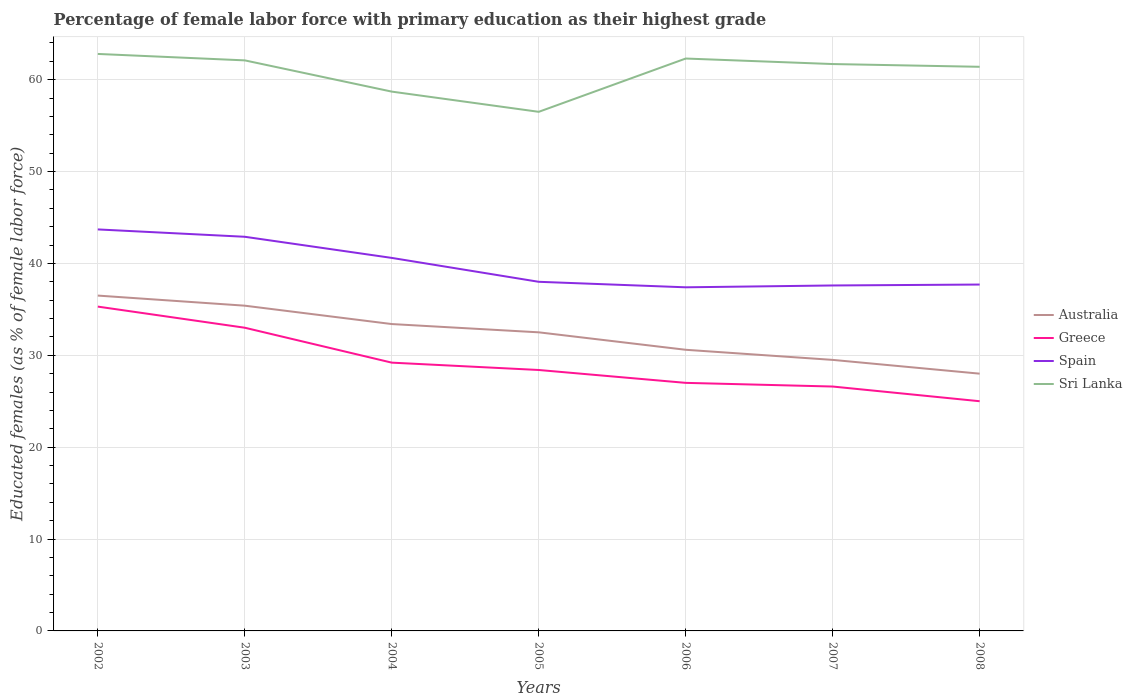In which year was the percentage of female labor force with primary education in Australia maximum?
Ensure brevity in your answer.  2008. What is the total percentage of female labor force with primary education in Greece in the graph?
Give a very brief answer. 6. What is the difference between the highest and the second highest percentage of female labor force with primary education in Greece?
Make the answer very short. 10.3. What is the difference between the highest and the lowest percentage of female labor force with primary education in Australia?
Keep it short and to the point. 4. Is the percentage of female labor force with primary education in Sri Lanka strictly greater than the percentage of female labor force with primary education in Greece over the years?
Ensure brevity in your answer.  No. How many years are there in the graph?
Ensure brevity in your answer.  7. What is the difference between two consecutive major ticks on the Y-axis?
Offer a very short reply. 10. What is the title of the graph?
Your response must be concise. Percentage of female labor force with primary education as their highest grade. Does "Burundi" appear as one of the legend labels in the graph?
Make the answer very short. No. What is the label or title of the X-axis?
Offer a terse response. Years. What is the label or title of the Y-axis?
Offer a very short reply. Educated females (as % of female labor force). What is the Educated females (as % of female labor force) in Australia in 2002?
Ensure brevity in your answer.  36.5. What is the Educated females (as % of female labor force) in Greece in 2002?
Your answer should be very brief. 35.3. What is the Educated females (as % of female labor force) in Spain in 2002?
Your answer should be compact. 43.7. What is the Educated females (as % of female labor force) in Sri Lanka in 2002?
Ensure brevity in your answer.  62.8. What is the Educated females (as % of female labor force) in Australia in 2003?
Give a very brief answer. 35.4. What is the Educated females (as % of female labor force) of Spain in 2003?
Keep it short and to the point. 42.9. What is the Educated females (as % of female labor force) in Sri Lanka in 2003?
Offer a very short reply. 62.1. What is the Educated females (as % of female labor force) of Australia in 2004?
Ensure brevity in your answer.  33.4. What is the Educated females (as % of female labor force) of Greece in 2004?
Provide a succinct answer. 29.2. What is the Educated females (as % of female labor force) in Spain in 2004?
Offer a terse response. 40.6. What is the Educated females (as % of female labor force) of Sri Lanka in 2004?
Offer a terse response. 58.7. What is the Educated females (as % of female labor force) of Australia in 2005?
Ensure brevity in your answer.  32.5. What is the Educated females (as % of female labor force) in Greece in 2005?
Provide a short and direct response. 28.4. What is the Educated females (as % of female labor force) in Spain in 2005?
Ensure brevity in your answer.  38. What is the Educated females (as % of female labor force) of Sri Lanka in 2005?
Provide a short and direct response. 56.5. What is the Educated females (as % of female labor force) of Australia in 2006?
Give a very brief answer. 30.6. What is the Educated females (as % of female labor force) of Spain in 2006?
Keep it short and to the point. 37.4. What is the Educated females (as % of female labor force) of Sri Lanka in 2006?
Keep it short and to the point. 62.3. What is the Educated females (as % of female labor force) of Australia in 2007?
Your answer should be compact. 29.5. What is the Educated females (as % of female labor force) of Greece in 2007?
Your response must be concise. 26.6. What is the Educated females (as % of female labor force) in Spain in 2007?
Your response must be concise. 37.6. What is the Educated females (as % of female labor force) in Sri Lanka in 2007?
Ensure brevity in your answer.  61.7. What is the Educated females (as % of female labor force) of Spain in 2008?
Provide a short and direct response. 37.7. What is the Educated females (as % of female labor force) of Sri Lanka in 2008?
Offer a terse response. 61.4. Across all years, what is the maximum Educated females (as % of female labor force) in Australia?
Provide a short and direct response. 36.5. Across all years, what is the maximum Educated females (as % of female labor force) of Greece?
Provide a succinct answer. 35.3. Across all years, what is the maximum Educated females (as % of female labor force) in Spain?
Provide a succinct answer. 43.7. Across all years, what is the maximum Educated females (as % of female labor force) of Sri Lanka?
Your response must be concise. 62.8. Across all years, what is the minimum Educated females (as % of female labor force) in Greece?
Provide a short and direct response. 25. Across all years, what is the minimum Educated females (as % of female labor force) of Spain?
Your answer should be compact. 37.4. Across all years, what is the minimum Educated females (as % of female labor force) in Sri Lanka?
Make the answer very short. 56.5. What is the total Educated females (as % of female labor force) in Australia in the graph?
Provide a succinct answer. 225.9. What is the total Educated females (as % of female labor force) in Greece in the graph?
Give a very brief answer. 204.5. What is the total Educated females (as % of female labor force) of Spain in the graph?
Offer a terse response. 277.9. What is the total Educated females (as % of female labor force) in Sri Lanka in the graph?
Offer a terse response. 425.5. What is the difference between the Educated females (as % of female labor force) in Australia in 2002 and that in 2003?
Give a very brief answer. 1.1. What is the difference between the Educated females (as % of female labor force) in Spain in 2002 and that in 2003?
Your answer should be very brief. 0.8. What is the difference between the Educated females (as % of female labor force) in Sri Lanka in 2002 and that in 2003?
Ensure brevity in your answer.  0.7. What is the difference between the Educated females (as % of female labor force) in Spain in 2002 and that in 2004?
Make the answer very short. 3.1. What is the difference between the Educated females (as % of female labor force) of Sri Lanka in 2002 and that in 2004?
Your answer should be very brief. 4.1. What is the difference between the Educated females (as % of female labor force) of Australia in 2002 and that in 2005?
Your response must be concise. 4. What is the difference between the Educated females (as % of female labor force) of Sri Lanka in 2002 and that in 2005?
Your answer should be compact. 6.3. What is the difference between the Educated females (as % of female labor force) in Spain in 2002 and that in 2006?
Make the answer very short. 6.3. What is the difference between the Educated females (as % of female labor force) in Australia in 2002 and that in 2007?
Your answer should be very brief. 7. What is the difference between the Educated females (as % of female labor force) in Australia in 2002 and that in 2008?
Your response must be concise. 8.5. What is the difference between the Educated females (as % of female labor force) of Greece in 2002 and that in 2008?
Offer a terse response. 10.3. What is the difference between the Educated females (as % of female labor force) in Australia in 2003 and that in 2005?
Ensure brevity in your answer.  2.9. What is the difference between the Educated females (as % of female labor force) of Australia in 2003 and that in 2006?
Offer a terse response. 4.8. What is the difference between the Educated females (as % of female labor force) in Spain in 2003 and that in 2006?
Make the answer very short. 5.5. What is the difference between the Educated females (as % of female labor force) in Sri Lanka in 2003 and that in 2006?
Ensure brevity in your answer.  -0.2. What is the difference between the Educated females (as % of female labor force) of Greece in 2003 and that in 2007?
Ensure brevity in your answer.  6.4. What is the difference between the Educated females (as % of female labor force) in Spain in 2003 and that in 2007?
Offer a terse response. 5.3. What is the difference between the Educated females (as % of female labor force) in Australia in 2003 and that in 2008?
Provide a short and direct response. 7.4. What is the difference between the Educated females (as % of female labor force) in Spain in 2004 and that in 2005?
Give a very brief answer. 2.6. What is the difference between the Educated females (as % of female labor force) of Spain in 2004 and that in 2006?
Your answer should be very brief. 3.2. What is the difference between the Educated females (as % of female labor force) of Sri Lanka in 2004 and that in 2006?
Your answer should be compact. -3.6. What is the difference between the Educated females (as % of female labor force) of Australia in 2004 and that in 2007?
Make the answer very short. 3.9. What is the difference between the Educated females (as % of female labor force) of Greece in 2004 and that in 2007?
Ensure brevity in your answer.  2.6. What is the difference between the Educated females (as % of female labor force) in Sri Lanka in 2004 and that in 2007?
Your response must be concise. -3. What is the difference between the Educated females (as % of female labor force) of Spain in 2004 and that in 2008?
Your answer should be very brief. 2.9. What is the difference between the Educated females (as % of female labor force) of Australia in 2005 and that in 2006?
Offer a terse response. 1.9. What is the difference between the Educated females (as % of female labor force) of Spain in 2005 and that in 2006?
Your response must be concise. 0.6. What is the difference between the Educated females (as % of female labor force) in Sri Lanka in 2005 and that in 2006?
Keep it short and to the point. -5.8. What is the difference between the Educated females (as % of female labor force) of Spain in 2005 and that in 2007?
Offer a very short reply. 0.4. What is the difference between the Educated females (as % of female labor force) in Australia in 2005 and that in 2008?
Your response must be concise. 4.5. What is the difference between the Educated females (as % of female labor force) in Greece in 2005 and that in 2008?
Ensure brevity in your answer.  3.4. What is the difference between the Educated females (as % of female labor force) of Spain in 2005 and that in 2008?
Your answer should be very brief. 0.3. What is the difference between the Educated females (as % of female labor force) of Greece in 2006 and that in 2007?
Provide a short and direct response. 0.4. What is the difference between the Educated females (as % of female labor force) of Spain in 2006 and that in 2007?
Provide a short and direct response. -0.2. What is the difference between the Educated females (as % of female labor force) in Australia in 2006 and that in 2008?
Give a very brief answer. 2.6. What is the difference between the Educated females (as % of female labor force) in Greece in 2006 and that in 2008?
Your answer should be very brief. 2. What is the difference between the Educated females (as % of female labor force) in Australia in 2007 and that in 2008?
Provide a succinct answer. 1.5. What is the difference between the Educated females (as % of female labor force) in Sri Lanka in 2007 and that in 2008?
Your answer should be very brief. 0.3. What is the difference between the Educated females (as % of female labor force) of Australia in 2002 and the Educated females (as % of female labor force) of Spain in 2003?
Provide a short and direct response. -6.4. What is the difference between the Educated females (as % of female labor force) of Australia in 2002 and the Educated females (as % of female labor force) of Sri Lanka in 2003?
Offer a very short reply. -25.6. What is the difference between the Educated females (as % of female labor force) in Greece in 2002 and the Educated females (as % of female labor force) in Sri Lanka in 2003?
Give a very brief answer. -26.8. What is the difference between the Educated females (as % of female labor force) of Spain in 2002 and the Educated females (as % of female labor force) of Sri Lanka in 2003?
Give a very brief answer. -18.4. What is the difference between the Educated females (as % of female labor force) of Australia in 2002 and the Educated females (as % of female labor force) of Spain in 2004?
Provide a short and direct response. -4.1. What is the difference between the Educated females (as % of female labor force) of Australia in 2002 and the Educated females (as % of female labor force) of Sri Lanka in 2004?
Offer a very short reply. -22.2. What is the difference between the Educated females (as % of female labor force) in Greece in 2002 and the Educated females (as % of female labor force) in Spain in 2004?
Give a very brief answer. -5.3. What is the difference between the Educated females (as % of female labor force) in Greece in 2002 and the Educated females (as % of female labor force) in Sri Lanka in 2004?
Make the answer very short. -23.4. What is the difference between the Educated females (as % of female labor force) of Australia in 2002 and the Educated females (as % of female labor force) of Greece in 2005?
Your answer should be very brief. 8.1. What is the difference between the Educated females (as % of female labor force) of Australia in 2002 and the Educated females (as % of female labor force) of Spain in 2005?
Your answer should be very brief. -1.5. What is the difference between the Educated females (as % of female labor force) of Australia in 2002 and the Educated females (as % of female labor force) of Sri Lanka in 2005?
Your answer should be very brief. -20. What is the difference between the Educated females (as % of female labor force) of Greece in 2002 and the Educated females (as % of female labor force) of Sri Lanka in 2005?
Provide a short and direct response. -21.2. What is the difference between the Educated females (as % of female labor force) of Australia in 2002 and the Educated females (as % of female labor force) of Greece in 2006?
Provide a succinct answer. 9.5. What is the difference between the Educated females (as % of female labor force) of Australia in 2002 and the Educated females (as % of female labor force) of Spain in 2006?
Ensure brevity in your answer.  -0.9. What is the difference between the Educated females (as % of female labor force) in Australia in 2002 and the Educated females (as % of female labor force) in Sri Lanka in 2006?
Offer a very short reply. -25.8. What is the difference between the Educated females (as % of female labor force) of Greece in 2002 and the Educated females (as % of female labor force) of Spain in 2006?
Offer a terse response. -2.1. What is the difference between the Educated females (as % of female labor force) of Greece in 2002 and the Educated females (as % of female labor force) of Sri Lanka in 2006?
Provide a short and direct response. -27. What is the difference between the Educated females (as % of female labor force) in Spain in 2002 and the Educated females (as % of female labor force) in Sri Lanka in 2006?
Give a very brief answer. -18.6. What is the difference between the Educated females (as % of female labor force) of Australia in 2002 and the Educated females (as % of female labor force) of Greece in 2007?
Offer a terse response. 9.9. What is the difference between the Educated females (as % of female labor force) of Australia in 2002 and the Educated females (as % of female labor force) of Spain in 2007?
Give a very brief answer. -1.1. What is the difference between the Educated females (as % of female labor force) in Australia in 2002 and the Educated females (as % of female labor force) in Sri Lanka in 2007?
Your answer should be compact. -25.2. What is the difference between the Educated females (as % of female labor force) of Greece in 2002 and the Educated females (as % of female labor force) of Sri Lanka in 2007?
Keep it short and to the point. -26.4. What is the difference between the Educated females (as % of female labor force) in Australia in 2002 and the Educated females (as % of female labor force) in Spain in 2008?
Provide a succinct answer. -1.2. What is the difference between the Educated females (as % of female labor force) of Australia in 2002 and the Educated females (as % of female labor force) of Sri Lanka in 2008?
Keep it short and to the point. -24.9. What is the difference between the Educated females (as % of female labor force) of Greece in 2002 and the Educated females (as % of female labor force) of Sri Lanka in 2008?
Provide a short and direct response. -26.1. What is the difference between the Educated females (as % of female labor force) in Spain in 2002 and the Educated females (as % of female labor force) in Sri Lanka in 2008?
Keep it short and to the point. -17.7. What is the difference between the Educated females (as % of female labor force) of Australia in 2003 and the Educated females (as % of female labor force) of Sri Lanka in 2004?
Provide a succinct answer. -23.3. What is the difference between the Educated females (as % of female labor force) of Greece in 2003 and the Educated females (as % of female labor force) of Spain in 2004?
Your answer should be compact. -7.6. What is the difference between the Educated females (as % of female labor force) of Greece in 2003 and the Educated females (as % of female labor force) of Sri Lanka in 2004?
Your response must be concise. -25.7. What is the difference between the Educated females (as % of female labor force) of Spain in 2003 and the Educated females (as % of female labor force) of Sri Lanka in 2004?
Offer a terse response. -15.8. What is the difference between the Educated females (as % of female labor force) of Australia in 2003 and the Educated females (as % of female labor force) of Sri Lanka in 2005?
Offer a terse response. -21.1. What is the difference between the Educated females (as % of female labor force) of Greece in 2003 and the Educated females (as % of female labor force) of Spain in 2005?
Keep it short and to the point. -5. What is the difference between the Educated females (as % of female labor force) of Greece in 2003 and the Educated females (as % of female labor force) of Sri Lanka in 2005?
Provide a short and direct response. -23.5. What is the difference between the Educated females (as % of female labor force) in Spain in 2003 and the Educated females (as % of female labor force) in Sri Lanka in 2005?
Ensure brevity in your answer.  -13.6. What is the difference between the Educated females (as % of female labor force) of Australia in 2003 and the Educated females (as % of female labor force) of Spain in 2006?
Make the answer very short. -2. What is the difference between the Educated females (as % of female labor force) of Australia in 2003 and the Educated females (as % of female labor force) of Sri Lanka in 2006?
Offer a terse response. -26.9. What is the difference between the Educated females (as % of female labor force) of Greece in 2003 and the Educated females (as % of female labor force) of Spain in 2006?
Provide a succinct answer. -4.4. What is the difference between the Educated females (as % of female labor force) of Greece in 2003 and the Educated females (as % of female labor force) of Sri Lanka in 2006?
Ensure brevity in your answer.  -29.3. What is the difference between the Educated females (as % of female labor force) in Spain in 2003 and the Educated females (as % of female labor force) in Sri Lanka in 2006?
Make the answer very short. -19.4. What is the difference between the Educated females (as % of female labor force) in Australia in 2003 and the Educated females (as % of female labor force) in Spain in 2007?
Offer a terse response. -2.2. What is the difference between the Educated females (as % of female labor force) of Australia in 2003 and the Educated females (as % of female labor force) of Sri Lanka in 2007?
Make the answer very short. -26.3. What is the difference between the Educated females (as % of female labor force) in Greece in 2003 and the Educated females (as % of female labor force) in Spain in 2007?
Provide a succinct answer. -4.6. What is the difference between the Educated females (as % of female labor force) in Greece in 2003 and the Educated females (as % of female labor force) in Sri Lanka in 2007?
Make the answer very short. -28.7. What is the difference between the Educated females (as % of female labor force) of Spain in 2003 and the Educated females (as % of female labor force) of Sri Lanka in 2007?
Offer a terse response. -18.8. What is the difference between the Educated females (as % of female labor force) of Greece in 2003 and the Educated females (as % of female labor force) of Spain in 2008?
Give a very brief answer. -4.7. What is the difference between the Educated females (as % of female labor force) of Greece in 2003 and the Educated females (as % of female labor force) of Sri Lanka in 2008?
Your answer should be compact. -28.4. What is the difference between the Educated females (as % of female labor force) in Spain in 2003 and the Educated females (as % of female labor force) in Sri Lanka in 2008?
Provide a short and direct response. -18.5. What is the difference between the Educated females (as % of female labor force) of Australia in 2004 and the Educated females (as % of female labor force) of Spain in 2005?
Make the answer very short. -4.6. What is the difference between the Educated females (as % of female labor force) of Australia in 2004 and the Educated females (as % of female labor force) of Sri Lanka in 2005?
Your answer should be compact. -23.1. What is the difference between the Educated females (as % of female labor force) of Greece in 2004 and the Educated females (as % of female labor force) of Spain in 2005?
Your answer should be very brief. -8.8. What is the difference between the Educated females (as % of female labor force) of Greece in 2004 and the Educated females (as % of female labor force) of Sri Lanka in 2005?
Provide a succinct answer. -27.3. What is the difference between the Educated females (as % of female labor force) in Spain in 2004 and the Educated females (as % of female labor force) in Sri Lanka in 2005?
Provide a succinct answer. -15.9. What is the difference between the Educated females (as % of female labor force) of Australia in 2004 and the Educated females (as % of female labor force) of Sri Lanka in 2006?
Make the answer very short. -28.9. What is the difference between the Educated females (as % of female labor force) in Greece in 2004 and the Educated females (as % of female labor force) in Spain in 2006?
Keep it short and to the point. -8.2. What is the difference between the Educated females (as % of female labor force) in Greece in 2004 and the Educated females (as % of female labor force) in Sri Lanka in 2006?
Your answer should be compact. -33.1. What is the difference between the Educated females (as % of female labor force) of Spain in 2004 and the Educated females (as % of female labor force) of Sri Lanka in 2006?
Provide a succinct answer. -21.7. What is the difference between the Educated females (as % of female labor force) in Australia in 2004 and the Educated females (as % of female labor force) in Spain in 2007?
Your response must be concise. -4.2. What is the difference between the Educated females (as % of female labor force) of Australia in 2004 and the Educated females (as % of female labor force) of Sri Lanka in 2007?
Give a very brief answer. -28.3. What is the difference between the Educated females (as % of female labor force) in Greece in 2004 and the Educated females (as % of female labor force) in Sri Lanka in 2007?
Your answer should be very brief. -32.5. What is the difference between the Educated females (as % of female labor force) of Spain in 2004 and the Educated females (as % of female labor force) of Sri Lanka in 2007?
Your answer should be compact. -21.1. What is the difference between the Educated females (as % of female labor force) in Australia in 2004 and the Educated females (as % of female labor force) in Sri Lanka in 2008?
Provide a short and direct response. -28. What is the difference between the Educated females (as % of female labor force) of Greece in 2004 and the Educated females (as % of female labor force) of Spain in 2008?
Your answer should be very brief. -8.5. What is the difference between the Educated females (as % of female labor force) of Greece in 2004 and the Educated females (as % of female labor force) of Sri Lanka in 2008?
Offer a terse response. -32.2. What is the difference between the Educated females (as % of female labor force) of Spain in 2004 and the Educated females (as % of female labor force) of Sri Lanka in 2008?
Ensure brevity in your answer.  -20.8. What is the difference between the Educated females (as % of female labor force) in Australia in 2005 and the Educated females (as % of female labor force) in Spain in 2006?
Your answer should be very brief. -4.9. What is the difference between the Educated females (as % of female labor force) of Australia in 2005 and the Educated females (as % of female labor force) of Sri Lanka in 2006?
Give a very brief answer. -29.8. What is the difference between the Educated females (as % of female labor force) in Greece in 2005 and the Educated females (as % of female labor force) in Sri Lanka in 2006?
Give a very brief answer. -33.9. What is the difference between the Educated females (as % of female labor force) of Spain in 2005 and the Educated females (as % of female labor force) of Sri Lanka in 2006?
Your response must be concise. -24.3. What is the difference between the Educated females (as % of female labor force) of Australia in 2005 and the Educated females (as % of female labor force) of Sri Lanka in 2007?
Your response must be concise. -29.2. What is the difference between the Educated females (as % of female labor force) of Greece in 2005 and the Educated females (as % of female labor force) of Sri Lanka in 2007?
Provide a short and direct response. -33.3. What is the difference between the Educated females (as % of female labor force) of Spain in 2005 and the Educated females (as % of female labor force) of Sri Lanka in 2007?
Provide a short and direct response. -23.7. What is the difference between the Educated females (as % of female labor force) of Australia in 2005 and the Educated females (as % of female labor force) of Sri Lanka in 2008?
Offer a very short reply. -28.9. What is the difference between the Educated females (as % of female labor force) in Greece in 2005 and the Educated females (as % of female labor force) in Spain in 2008?
Your answer should be compact. -9.3. What is the difference between the Educated females (as % of female labor force) of Greece in 2005 and the Educated females (as % of female labor force) of Sri Lanka in 2008?
Provide a succinct answer. -33. What is the difference between the Educated females (as % of female labor force) of Spain in 2005 and the Educated females (as % of female labor force) of Sri Lanka in 2008?
Your answer should be compact. -23.4. What is the difference between the Educated females (as % of female labor force) of Australia in 2006 and the Educated females (as % of female labor force) of Greece in 2007?
Your response must be concise. 4. What is the difference between the Educated females (as % of female labor force) of Australia in 2006 and the Educated females (as % of female labor force) of Spain in 2007?
Your answer should be very brief. -7. What is the difference between the Educated females (as % of female labor force) in Australia in 2006 and the Educated females (as % of female labor force) in Sri Lanka in 2007?
Provide a short and direct response. -31.1. What is the difference between the Educated females (as % of female labor force) in Greece in 2006 and the Educated females (as % of female labor force) in Spain in 2007?
Provide a short and direct response. -10.6. What is the difference between the Educated females (as % of female labor force) in Greece in 2006 and the Educated females (as % of female labor force) in Sri Lanka in 2007?
Your response must be concise. -34.7. What is the difference between the Educated females (as % of female labor force) of Spain in 2006 and the Educated females (as % of female labor force) of Sri Lanka in 2007?
Provide a succinct answer. -24.3. What is the difference between the Educated females (as % of female labor force) in Australia in 2006 and the Educated females (as % of female labor force) in Greece in 2008?
Offer a very short reply. 5.6. What is the difference between the Educated females (as % of female labor force) of Australia in 2006 and the Educated females (as % of female labor force) of Spain in 2008?
Your response must be concise. -7.1. What is the difference between the Educated females (as % of female labor force) in Australia in 2006 and the Educated females (as % of female labor force) in Sri Lanka in 2008?
Keep it short and to the point. -30.8. What is the difference between the Educated females (as % of female labor force) in Greece in 2006 and the Educated females (as % of female labor force) in Sri Lanka in 2008?
Your answer should be very brief. -34.4. What is the difference between the Educated females (as % of female labor force) of Spain in 2006 and the Educated females (as % of female labor force) of Sri Lanka in 2008?
Offer a terse response. -24. What is the difference between the Educated females (as % of female labor force) in Australia in 2007 and the Educated females (as % of female labor force) in Greece in 2008?
Make the answer very short. 4.5. What is the difference between the Educated females (as % of female labor force) in Australia in 2007 and the Educated females (as % of female labor force) in Spain in 2008?
Give a very brief answer. -8.2. What is the difference between the Educated females (as % of female labor force) in Australia in 2007 and the Educated females (as % of female labor force) in Sri Lanka in 2008?
Your answer should be very brief. -31.9. What is the difference between the Educated females (as % of female labor force) of Greece in 2007 and the Educated females (as % of female labor force) of Spain in 2008?
Your answer should be compact. -11.1. What is the difference between the Educated females (as % of female labor force) of Greece in 2007 and the Educated females (as % of female labor force) of Sri Lanka in 2008?
Provide a short and direct response. -34.8. What is the difference between the Educated females (as % of female labor force) in Spain in 2007 and the Educated females (as % of female labor force) in Sri Lanka in 2008?
Provide a short and direct response. -23.8. What is the average Educated females (as % of female labor force) of Australia per year?
Your response must be concise. 32.27. What is the average Educated females (as % of female labor force) in Greece per year?
Keep it short and to the point. 29.21. What is the average Educated females (as % of female labor force) in Spain per year?
Your answer should be very brief. 39.7. What is the average Educated females (as % of female labor force) of Sri Lanka per year?
Give a very brief answer. 60.79. In the year 2002, what is the difference between the Educated females (as % of female labor force) of Australia and Educated females (as % of female labor force) of Sri Lanka?
Make the answer very short. -26.3. In the year 2002, what is the difference between the Educated females (as % of female labor force) in Greece and Educated females (as % of female labor force) in Spain?
Your response must be concise. -8.4. In the year 2002, what is the difference between the Educated females (as % of female labor force) in Greece and Educated females (as % of female labor force) in Sri Lanka?
Your answer should be very brief. -27.5. In the year 2002, what is the difference between the Educated females (as % of female labor force) of Spain and Educated females (as % of female labor force) of Sri Lanka?
Your answer should be very brief. -19.1. In the year 2003, what is the difference between the Educated females (as % of female labor force) in Australia and Educated females (as % of female labor force) in Greece?
Provide a succinct answer. 2.4. In the year 2003, what is the difference between the Educated females (as % of female labor force) in Australia and Educated females (as % of female labor force) in Spain?
Your response must be concise. -7.5. In the year 2003, what is the difference between the Educated females (as % of female labor force) of Australia and Educated females (as % of female labor force) of Sri Lanka?
Your answer should be compact. -26.7. In the year 2003, what is the difference between the Educated females (as % of female labor force) of Greece and Educated females (as % of female labor force) of Sri Lanka?
Offer a very short reply. -29.1. In the year 2003, what is the difference between the Educated females (as % of female labor force) in Spain and Educated females (as % of female labor force) in Sri Lanka?
Provide a short and direct response. -19.2. In the year 2004, what is the difference between the Educated females (as % of female labor force) in Australia and Educated females (as % of female labor force) in Greece?
Your response must be concise. 4.2. In the year 2004, what is the difference between the Educated females (as % of female labor force) in Australia and Educated females (as % of female labor force) in Spain?
Your answer should be very brief. -7.2. In the year 2004, what is the difference between the Educated females (as % of female labor force) of Australia and Educated females (as % of female labor force) of Sri Lanka?
Give a very brief answer. -25.3. In the year 2004, what is the difference between the Educated females (as % of female labor force) in Greece and Educated females (as % of female labor force) in Sri Lanka?
Provide a short and direct response. -29.5. In the year 2004, what is the difference between the Educated females (as % of female labor force) of Spain and Educated females (as % of female labor force) of Sri Lanka?
Offer a very short reply. -18.1. In the year 2005, what is the difference between the Educated females (as % of female labor force) of Australia and Educated females (as % of female labor force) of Greece?
Provide a short and direct response. 4.1. In the year 2005, what is the difference between the Educated females (as % of female labor force) of Australia and Educated females (as % of female labor force) of Spain?
Provide a succinct answer. -5.5. In the year 2005, what is the difference between the Educated females (as % of female labor force) in Greece and Educated females (as % of female labor force) in Sri Lanka?
Make the answer very short. -28.1. In the year 2005, what is the difference between the Educated females (as % of female labor force) in Spain and Educated females (as % of female labor force) in Sri Lanka?
Your response must be concise. -18.5. In the year 2006, what is the difference between the Educated females (as % of female labor force) of Australia and Educated females (as % of female labor force) of Sri Lanka?
Your answer should be very brief. -31.7. In the year 2006, what is the difference between the Educated females (as % of female labor force) in Greece and Educated females (as % of female labor force) in Spain?
Provide a succinct answer. -10.4. In the year 2006, what is the difference between the Educated females (as % of female labor force) of Greece and Educated females (as % of female labor force) of Sri Lanka?
Give a very brief answer. -35.3. In the year 2006, what is the difference between the Educated females (as % of female labor force) of Spain and Educated females (as % of female labor force) of Sri Lanka?
Offer a very short reply. -24.9. In the year 2007, what is the difference between the Educated females (as % of female labor force) of Australia and Educated females (as % of female labor force) of Greece?
Give a very brief answer. 2.9. In the year 2007, what is the difference between the Educated females (as % of female labor force) of Australia and Educated females (as % of female labor force) of Sri Lanka?
Make the answer very short. -32.2. In the year 2007, what is the difference between the Educated females (as % of female labor force) in Greece and Educated females (as % of female labor force) in Sri Lanka?
Your answer should be very brief. -35.1. In the year 2007, what is the difference between the Educated females (as % of female labor force) in Spain and Educated females (as % of female labor force) in Sri Lanka?
Make the answer very short. -24.1. In the year 2008, what is the difference between the Educated females (as % of female labor force) of Australia and Educated females (as % of female labor force) of Greece?
Offer a terse response. 3. In the year 2008, what is the difference between the Educated females (as % of female labor force) of Australia and Educated females (as % of female labor force) of Sri Lanka?
Your response must be concise. -33.4. In the year 2008, what is the difference between the Educated females (as % of female labor force) of Greece and Educated females (as % of female labor force) of Spain?
Offer a terse response. -12.7. In the year 2008, what is the difference between the Educated females (as % of female labor force) in Greece and Educated females (as % of female labor force) in Sri Lanka?
Ensure brevity in your answer.  -36.4. In the year 2008, what is the difference between the Educated females (as % of female labor force) of Spain and Educated females (as % of female labor force) of Sri Lanka?
Give a very brief answer. -23.7. What is the ratio of the Educated females (as % of female labor force) in Australia in 2002 to that in 2003?
Provide a succinct answer. 1.03. What is the ratio of the Educated females (as % of female labor force) in Greece in 2002 to that in 2003?
Give a very brief answer. 1.07. What is the ratio of the Educated females (as % of female labor force) of Spain in 2002 to that in 2003?
Your response must be concise. 1.02. What is the ratio of the Educated females (as % of female labor force) in Sri Lanka in 2002 to that in 2003?
Your answer should be very brief. 1.01. What is the ratio of the Educated females (as % of female labor force) of Australia in 2002 to that in 2004?
Provide a succinct answer. 1.09. What is the ratio of the Educated females (as % of female labor force) of Greece in 2002 to that in 2004?
Your answer should be compact. 1.21. What is the ratio of the Educated females (as % of female labor force) in Spain in 2002 to that in 2004?
Offer a terse response. 1.08. What is the ratio of the Educated females (as % of female labor force) of Sri Lanka in 2002 to that in 2004?
Ensure brevity in your answer.  1.07. What is the ratio of the Educated females (as % of female labor force) in Australia in 2002 to that in 2005?
Keep it short and to the point. 1.12. What is the ratio of the Educated females (as % of female labor force) of Greece in 2002 to that in 2005?
Offer a terse response. 1.24. What is the ratio of the Educated females (as % of female labor force) of Spain in 2002 to that in 2005?
Provide a short and direct response. 1.15. What is the ratio of the Educated females (as % of female labor force) of Sri Lanka in 2002 to that in 2005?
Provide a short and direct response. 1.11. What is the ratio of the Educated females (as % of female labor force) of Australia in 2002 to that in 2006?
Ensure brevity in your answer.  1.19. What is the ratio of the Educated females (as % of female labor force) of Greece in 2002 to that in 2006?
Keep it short and to the point. 1.31. What is the ratio of the Educated females (as % of female labor force) in Spain in 2002 to that in 2006?
Your answer should be compact. 1.17. What is the ratio of the Educated females (as % of female labor force) in Sri Lanka in 2002 to that in 2006?
Provide a succinct answer. 1.01. What is the ratio of the Educated females (as % of female labor force) of Australia in 2002 to that in 2007?
Ensure brevity in your answer.  1.24. What is the ratio of the Educated females (as % of female labor force) of Greece in 2002 to that in 2007?
Provide a succinct answer. 1.33. What is the ratio of the Educated females (as % of female labor force) in Spain in 2002 to that in 2007?
Your answer should be compact. 1.16. What is the ratio of the Educated females (as % of female labor force) of Sri Lanka in 2002 to that in 2007?
Make the answer very short. 1.02. What is the ratio of the Educated females (as % of female labor force) in Australia in 2002 to that in 2008?
Provide a succinct answer. 1.3. What is the ratio of the Educated females (as % of female labor force) of Greece in 2002 to that in 2008?
Offer a terse response. 1.41. What is the ratio of the Educated females (as % of female labor force) of Spain in 2002 to that in 2008?
Keep it short and to the point. 1.16. What is the ratio of the Educated females (as % of female labor force) of Sri Lanka in 2002 to that in 2008?
Keep it short and to the point. 1.02. What is the ratio of the Educated females (as % of female labor force) of Australia in 2003 to that in 2004?
Your answer should be compact. 1.06. What is the ratio of the Educated females (as % of female labor force) in Greece in 2003 to that in 2004?
Make the answer very short. 1.13. What is the ratio of the Educated females (as % of female labor force) of Spain in 2003 to that in 2004?
Offer a terse response. 1.06. What is the ratio of the Educated females (as % of female labor force) of Sri Lanka in 2003 to that in 2004?
Provide a short and direct response. 1.06. What is the ratio of the Educated females (as % of female labor force) of Australia in 2003 to that in 2005?
Make the answer very short. 1.09. What is the ratio of the Educated females (as % of female labor force) in Greece in 2003 to that in 2005?
Offer a terse response. 1.16. What is the ratio of the Educated females (as % of female labor force) of Spain in 2003 to that in 2005?
Keep it short and to the point. 1.13. What is the ratio of the Educated females (as % of female labor force) in Sri Lanka in 2003 to that in 2005?
Provide a succinct answer. 1.1. What is the ratio of the Educated females (as % of female labor force) in Australia in 2003 to that in 2006?
Offer a terse response. 1.16. What is the ratio of the Educated females (as % of female labor force) in Greece in 2003 to that in 2006?
Give a very brief answer. 1.22. What is the ratio of the Educated females (as % of female labor force) of Spain in 2003 to that in 2006?
Your response must be concise. 1.15. What is the ratio of the Educated females (as % of female labor force) of Sri Lanka in 2003 to that in 2006?
Your response must be concise. 1. What is the ratio of the Educated females (as % of female labor force) in Greece in 2003 to that in 2007?
Provide a succinct answer. 1.24. What is the ratio of the Educated females (as % of female labor force) of Spain in 2003 to that in 2007?
Make the answer very short. 1.14. What is the ratio of the Educated females (as % of female labor force) in Sri Lanka in 2003 to that in 2007?
Offer a terse response. 1.01. What is the ratio of the Educated females (as % of female labor force) in Australia in 2003 to that in 2008?
Provide a succinct answer. 1.26. What is the ratio of the Educated females (as % of female labor force) in Greece in 2003 to that in 2008?
Provide a succinct answer. 1.32. What is the ratio of the Educated females (as % of female labor force) of Spain in 2003 to that in 2008?
Your answer should be compact. 1.14. What is the ratio of the Educated females (as % of female labor force) in Sri Lanka in 2003 to that in 2008?
Your response must be concise. 1.01. What is the ratio of the Educated females (as % of female labor force) in Australia in 2004 to that in 2005?
Provide a succinct answer. 1.03. What is the ratio of the Educated females (as % of female labor force) of Greece in 2004 to that in 2005?
Ensure brevity in your answer.  1.03. What is the ratio of the Educated females (as % of female labor force) in Spain in 2004 to that in 2005?
Provide a succinct answer. 1.07. What is the ratio of the Educated females (as % of female labor force) in Sri Lanka in 2004 to that in 2005?
Provide a short and direct response. 1.04. What is the ratio of the Educated females (as % of female labor force) in Australia in 2004 to that in 2006?
Keep it short and to the point. 1.09. What is the ratio of the Educated females (as % of female labor force) in Greece in 2004 to that in 2006?
Your answer should be very brief. 1.08. What is the ratio of the Educated females (as % of female labor force) of Spain in 2004 to that in 2006?
Your answer should be compact. 1.09. What is the ratio of the Educated females (as % of female labor force) of Sri Lanka in 2004 to that in 2006?
Offer a terse response. 0.94. What is the ratio of the Educated females (as % of female labor force) of Australia in 2004 to that in 2007?
Provide a succinct answer. 1.13. What is the ratio of the Educated females (as % of female labor force) of Greece in 2004 to that in 2007?
Your answer should be very brief. 1.1. What is the ratio of the Educated females (as % of female labor force) in Spain in 2004 to that in 2007?
Provide a succinct answer. 1.08. What is the ratio of the Educated females (as % of female labor force) in Sri Lanka in 2004 to that in 2007?
Offer a terse response. 0.95. What is the ratio of the Educated females (as % of female labor force) of Australia in 2004 to that in 2008?
Offer a terse response. 1.19. What is the ratio of the Educated females (as % of female labor force) of Greece in 2004 to that in 2008?
Keep it short and to the point. 1.17. What is the ratio of the Educated females (as % of female labor force) in Sri Lanka in 2004 to that in 2008?
Offer a terse response. 0.96. What is the ratio of the Educated females (as % of female labor force) of Australia in 2005 to that in 2006?
Provide a short and direct response. 1.06. What is the ratio of the Educated females (as % of female labor force) in Greece in 2005 to that in 2006?
Give a very brief answer. 1.05. What is the ratio of the Educated females (as % of female labor force) of Spain in 2005 to that in 2006?
Provide a short and direct response. 1.02. What is the ratio of the Educated females (as % of female labor force) of Sri Lanka in 2005 to that in 2006?
Give a very brief answer. 0.91. What is the ratio of the Educated females (as % of female labor force) in Australia in 2005 to that in 2007?
Provide a succinct answer. 1.1. What is the ratio of the Educated females (as % of female labor force) in Greece in 2005 to that in 2007?
Provide a short and direct response. 1.07. What is the ratio of the Educated females (as % of female labor force) in Spain in 2005 to that in 2007?
Make the answer very short. 1.01. What is the ratio of the Educated females (as % of female labor force) of Sri Lanka in 2005 to that in 2007?
Ensure brevity in your answer.  0.92. What is the ratio of the Educated females (as % of female labor force) in Australia in 2005 to that in 2008?
Offer a very short reply. 1.16. What is the ratio of the Educated females (as % of female labor force) in Greece in 2005 to that in 2008?
Offer a very short reply. 1.14. What is the ratio of the Educated females (as % of female labor force) in Spain in 2005 to that in 2008?
Give a very brief answer. 1.01. What is the ratio of the Educated females (as % of female labor force) in Sri Lanka in 2005 to that in 2008?
Provide a short and direct response. 0.92. What is the ratio of the Educated females (as % of female labor force) in Australia in 2006 to that in 2007?
Offer a very short reply. 1.04. What is the ratio of the Educated females (as % of female labor force) in Sri Lanka in 2006 to that in 2007?
Offer a terse response. 1.01. What is the ratio of the Educated females (as % of female labor force) in Australia in 2006 to that in 2008?
Give a very brief answer. 1.09. What is the ratio of the Educated females (as % of female labor force) of Sri Lanka in 2006 to that in 2008?
Ensure brevity in your answer.  1.01. What is the ratio of the Educated females (as % of female labor force) in Australia in 2007 to that in 2008?
Make the answer very short. 1.05. What is the ratio of the Educated females (as % of female labor force) in Greece in 2007 to that in 2008?
Keep it short and to the point. 1.06. What is the ratio of the Educated females (as % of female labor force) in Spain in 2007 to that in 2008?
Make the answer very short. 1. What is the ratio of the Educated females (as % of female labor force) in Sri Lanka in 2007 to that in 2008?
Make the answer very short. 1. What is the difference between the highest and the lowest Educated females (as % of female labor force) in Greece?
Keep it short and to the point. 10.3. What is the difference between the highest and the lowest Educated females (as % of female labor force) in Sri Lanka?
Ensure brevity in your answer.  6.3. 